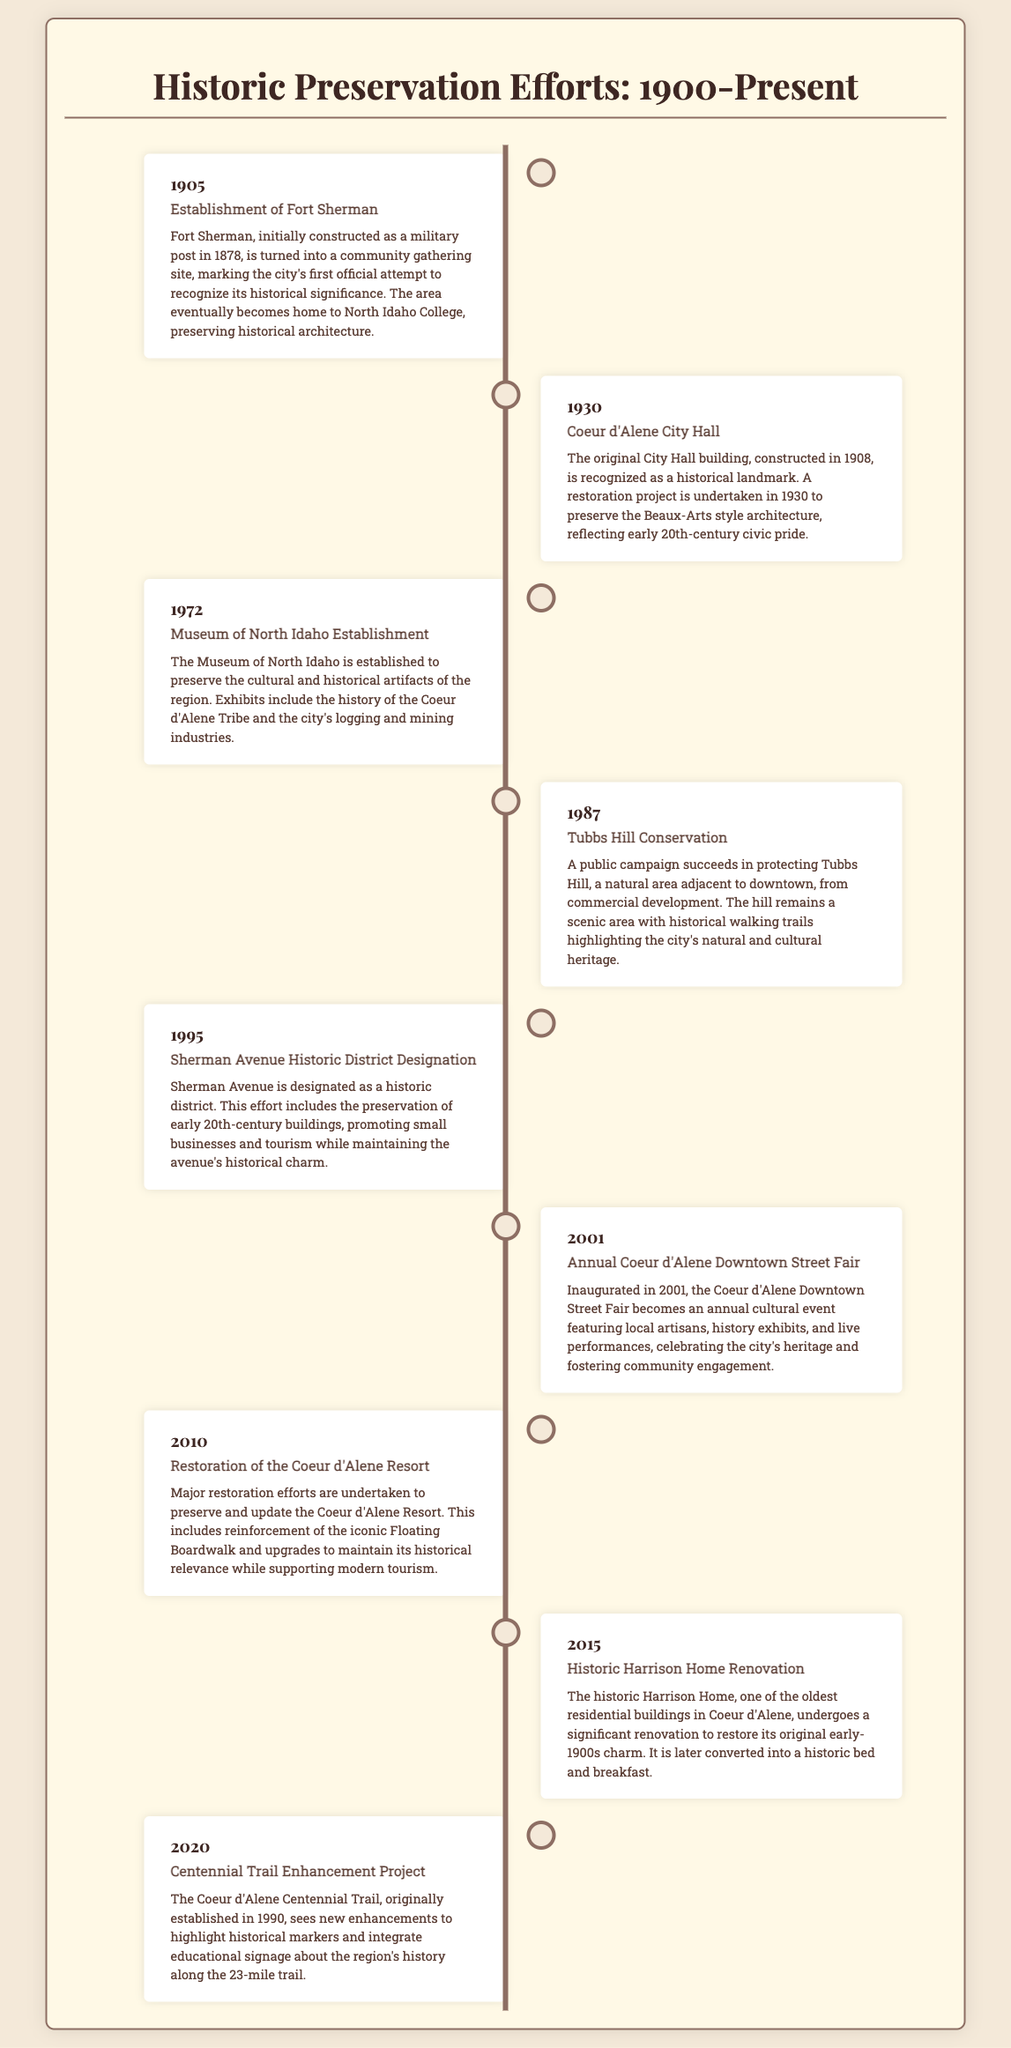What year did the establishment of Fort Sherman occur? The timeline entry for Fort Sherman states it was established in 1905.
Answer: 1905 What significant event occurred in 1930 related to Coeur d'Alene City Hall? The event mentions a restoration project undertaken in 1930 to preserve City Hall.
Answer: Restoration project What landmark was established in 1972? The document specifies that the Museum of North Idaho was established in 1972.
Answer: Museum of North Idaho Which natural area was conserved in 1987? The timeline entry notes that Tubbs Hill was successfully protected in 1987.
Answer: Tubbs Hill What is the purpose of the Coeur d'Alene Downtown Street Fair inaugurated in 2001? It is described as an annual cultural event celebrating the city's heritage and fostering community engagement.
Answer: Celebrate heritage In what year was Sherman Avenue designated as a historic district? The timeline states that the designation of Sherman Avenue occurred in 1995.
Answer: 1995 Which project highlights historical markers along the Centennial Trail? The timeline describes the Centennial Trail Enhancement Project as focusing on historical markers and educational signage.
Answer: Centennial Trail Enhancement Project How does the restoration of the Coeur d'Alene Resort relate to tourism? The document states that the restoration aimed to maintain historical relevance while supporting modern tourism.
Answer: Support tourism 